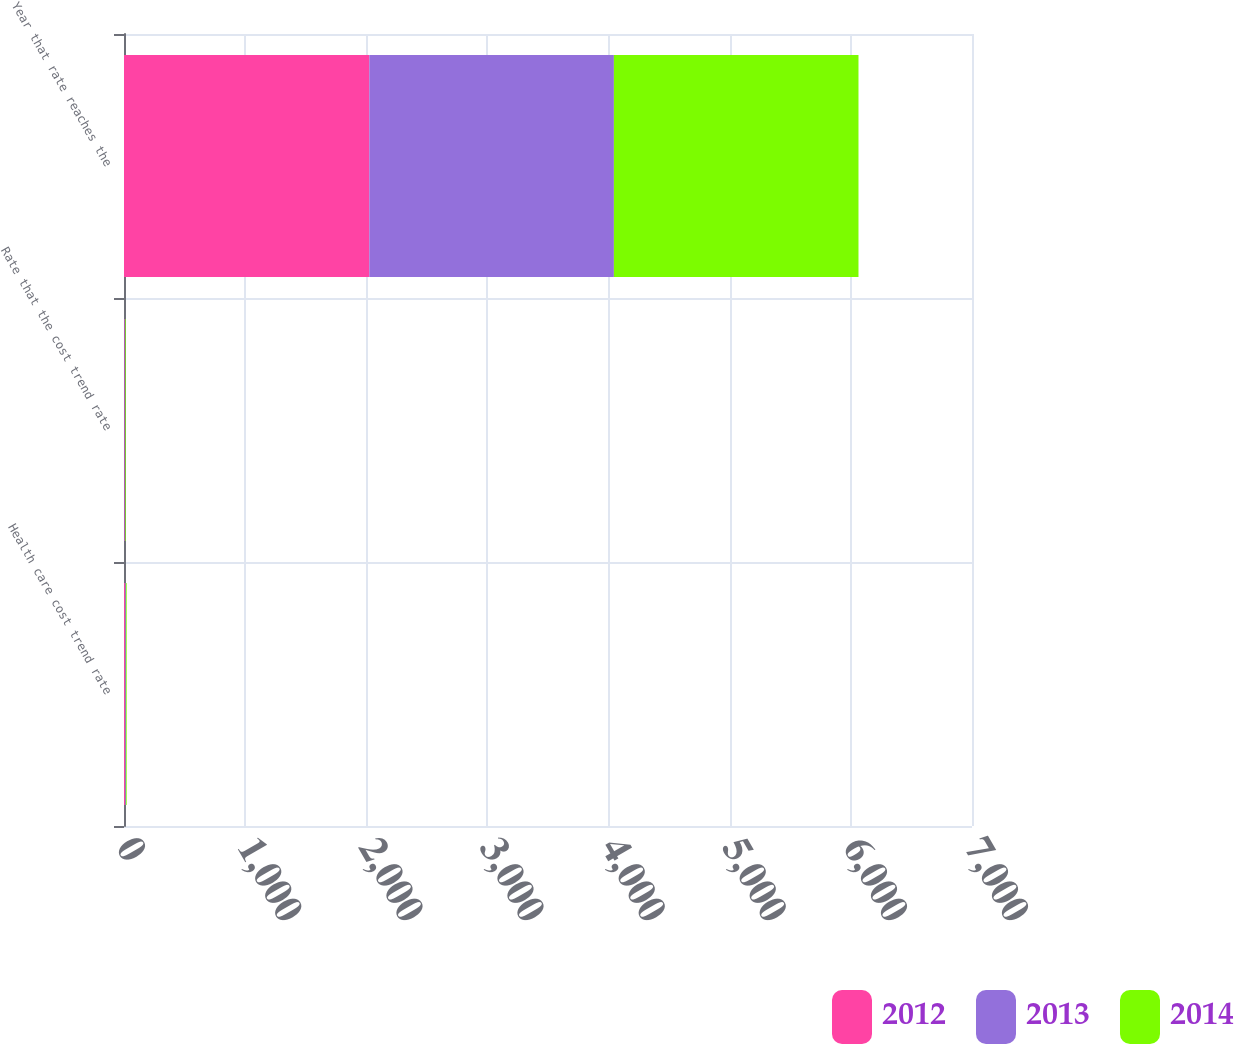Convert chart to OTSL. <chart><loc_0><loc_0><loc_500><loc_500><stacked_bar_chart><ecel><fcel>Health care cost trend rate<fcel>Rate that the cost trend rate<fcel>Year that rate reaches the<nl><fcel>2012<fcel>8<fcel>5<fcel>2025<nl><fcel>2013<fcel>7<fcel>5<fcel>2019<nl><fcel>2014<fcel>7<fcel>5<fcel>2019<nl></chart> 